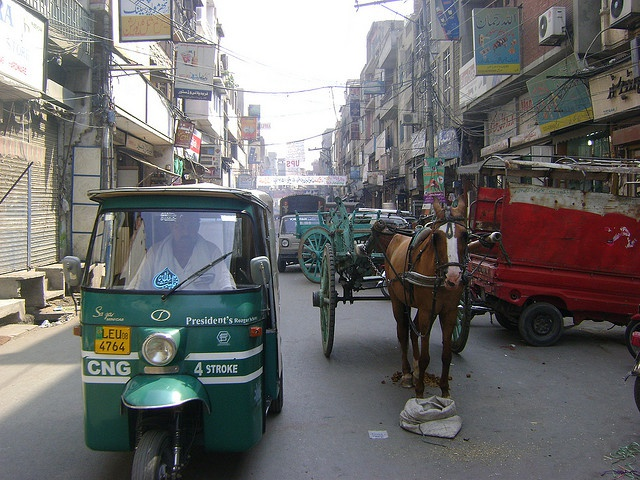Describe the objects in this image and their specific colors. I can see truck in gray, maroon, and black tones, horse in gray, black, and maroon tones, people in gray and darkgray tones, truck in gray, black, darkblue, and darkgray tones, and car in gray, darkgray, black, and lavender tones in this image. 